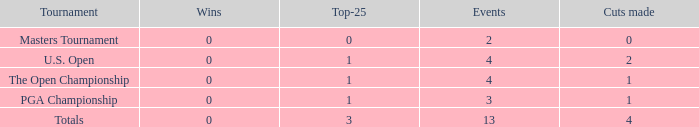How many cuts were made in the competition he participated in 13 times? None. 